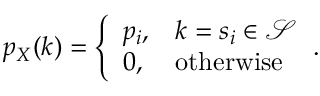Convert formula to latex. <formula><loc_0><loc_0><loc_500><loc_500>p _ { X } ( k ) = { \left \{ \begin{array} { l l } { p _ { i } , } & { k = s _ { i } \in { \mathcal { S } } } \\ { 0 , } & { o t h e r w i s e } \end{array} } .</formula> 